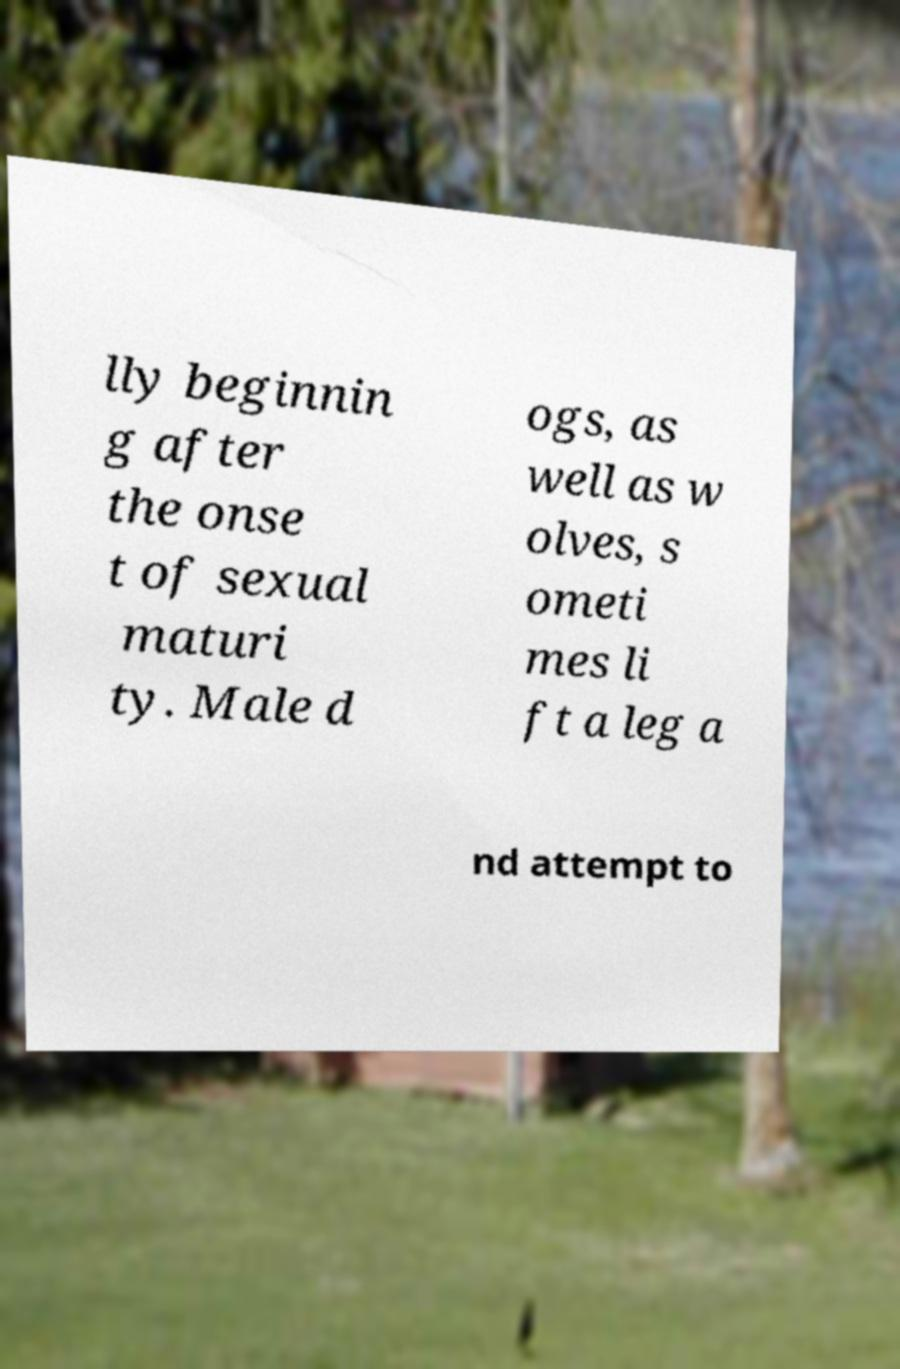Can you accurately transcribe the text from the provided image for me? lly beginnin g after the onse t of sexual maturi ty. Male d ogs, as well as w olves, s ometi mes li ft a leg a nd attempt to 